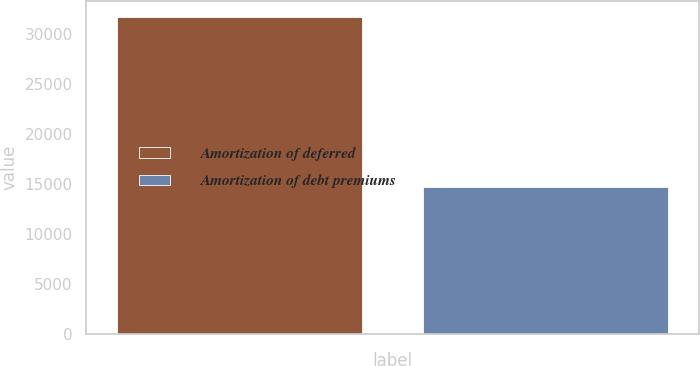Convert chart to OTSL. <chart><loc_0><loc_0><loc_500><loc_500><bar_chart><fcel>Amortization of deferred<fcel>Amortization of debt premiums<nl><fcel>31674<fcel>14701<nl></chart> 